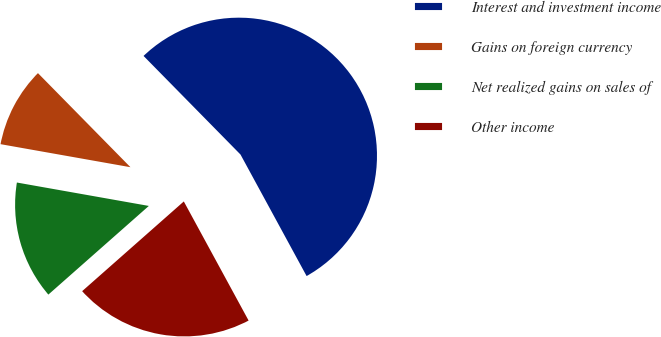Convert chart. <chart><loc_0><loc_0><loc_500><loc_500><pie_chart><fcel>Interest and investment income<fcel>Gains on foreign currency<fcel>Net realized gains on sales of<fcel>Other income<nl><fcel>54.43%<fcel>9.84%<fcel>14.3%<fcel>21.42%<nl></chart> 